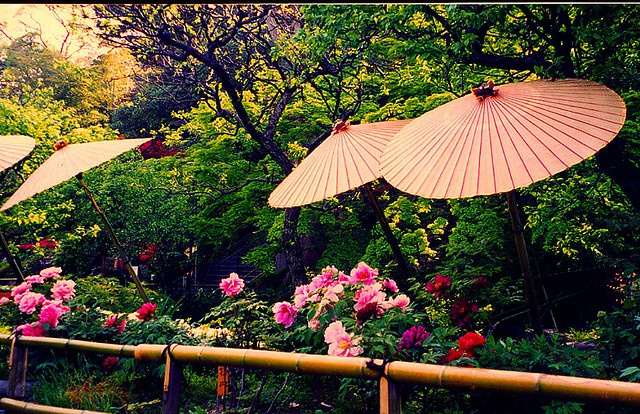Describe the objects in this image and their specific colors. I can see umbrella in black, tan, and salmon tones, umbrella in black, tan, salmon, and beige tones, umbrella in black, tan, ivory, and lightpink tones, and umbrella in black, tan, beige, and lightpink tones in this image. 